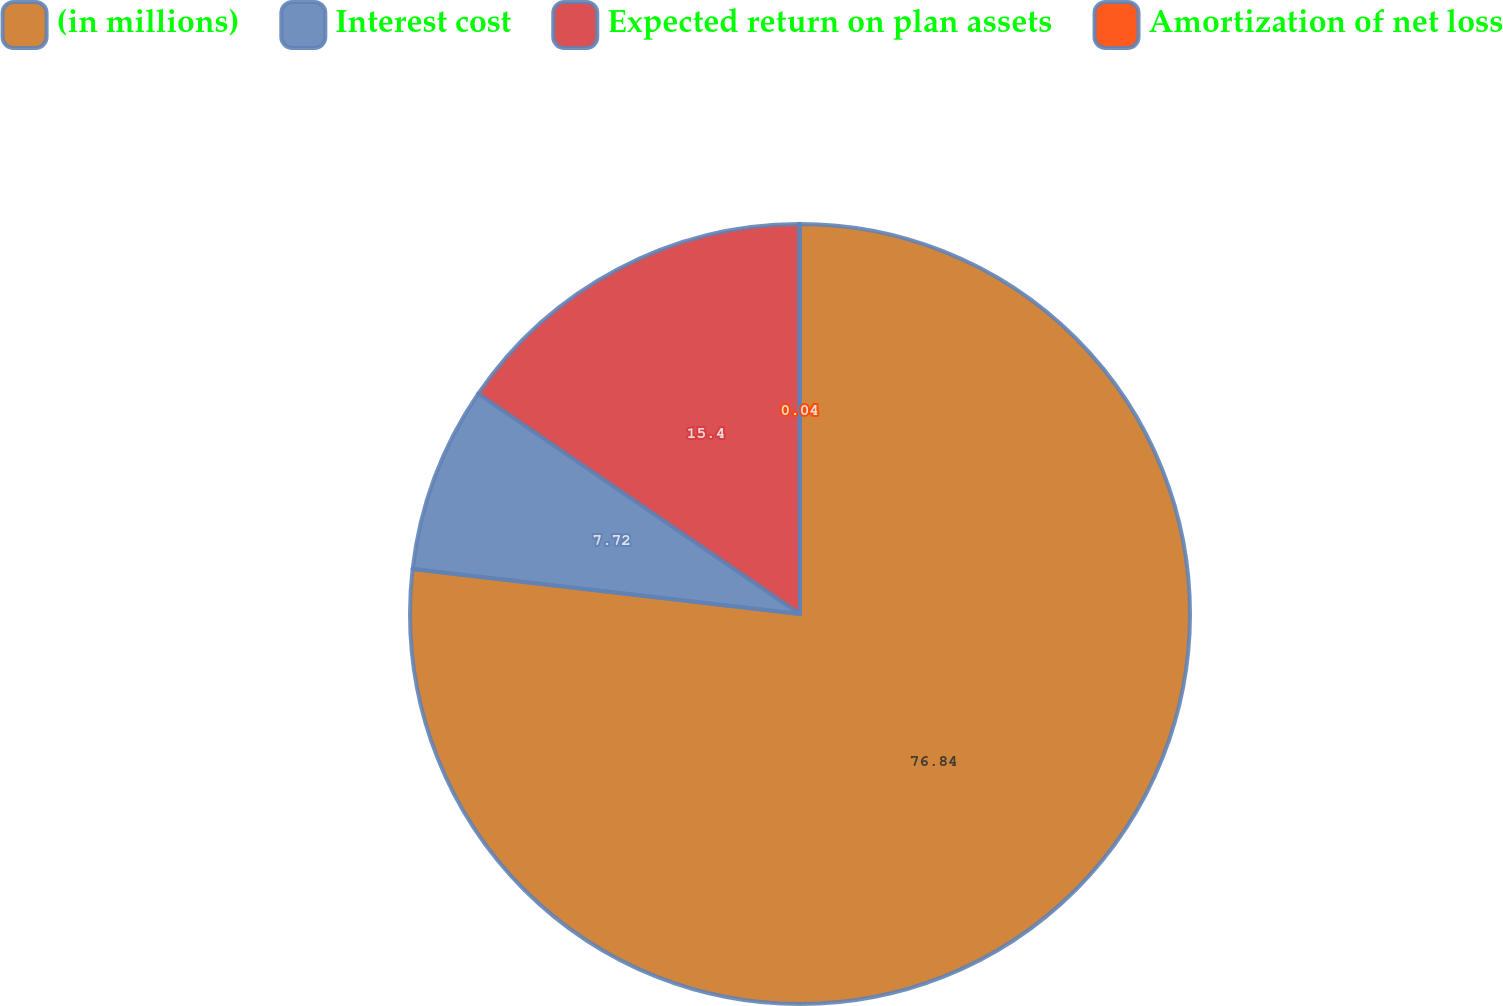Convert chart. <chart><loc_0><loc_0><loc_500><loc_500><pie_chart><fcel>(in millions)<fcel>Interest cost<fcel>Expected return on plan assets<fcel>Amortization of net loss<nl><fcel>76.84%<fcel>7.72%<fcel>15.4%<fcel>0.04%<nl></chart> 